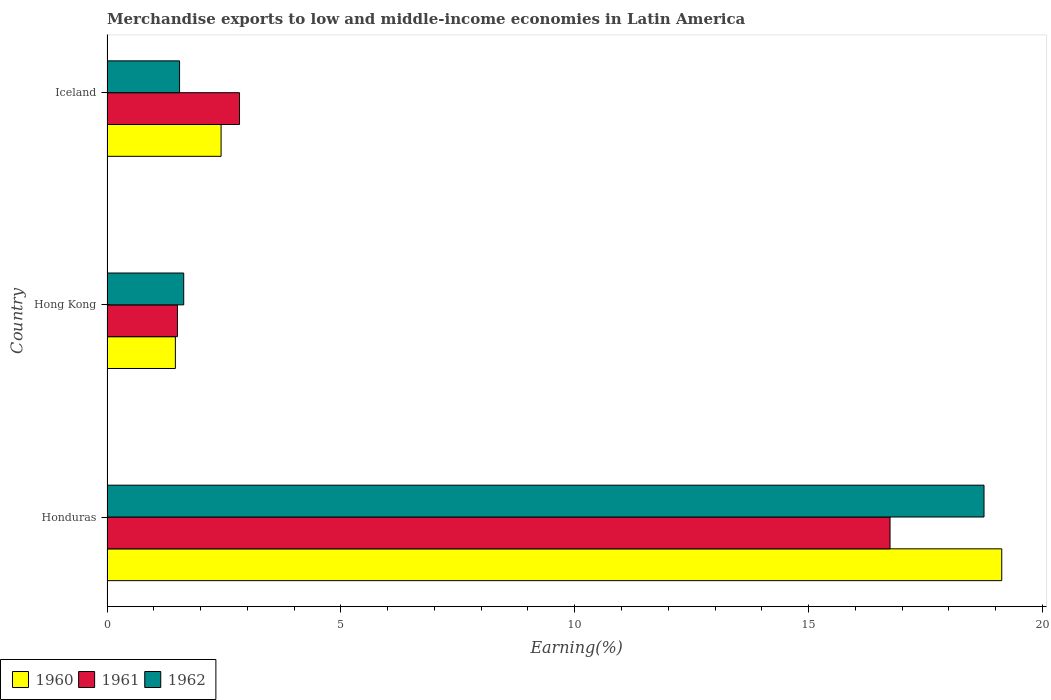How many different coloured bars are there?
Provide a short and direct response. 3. How many groups of bars are there?
Your response must be concise. 3. Are the number of bars per tick equal to the number of legend labels?
Make the answer very short. Yes. In how many cases, is the number of bars for a given country not equal to the number of legend labels?
Your answer should be compact. 0. What is the percentage of amount earned from merchandise exports in 1960 in Honduras?
Provide a succinct answer. 19.13. Across all countries, what is the maximum percentage of amount earned from merchandise exports in 1960?
Ensure brevity in your answer.  19.13. Across all countries, what is the minimum percentage of amount earned from merchandise exports in 1960?
Your answer should be very brief. 1.46. In which country was the percentage of amount earned from merchandise exports in 1961 maximum?
Offer a very short reply. Honduras. What is the total percentage of amount earned from merchandise exports in 1962 in the graph?
Offer a very short reply. 21.94. What is the difference between the percentage of amount earned from merchandise exports in 1962 in Honduras and that in Hong Kong?
Give a very brief answer. 17.11. What is the difference between the percentage of amount earned from merchandise exports in 1962 in Hong Kong and the percentage of amount earned from merchandise exports in 1960 in Honduras?
Offer a very short reply. -17.49. What is the average percentage of amount earned from merchandise exports in 1960 per country?
Provide a succinct answer. 7.68. What is the difference between the percentage of amount earned from merchandise exports in 1960 and percentage of amount earned from merchandise exports in 1961 in Honduras?
Ensure brevity in your answer.  2.39. In how many countries, is the percentage of amount earned from merchandise exports in 1962 greater than 10 %?
Make the answer very short. 1. What is the ratio of the percentage of amount earned from merchandise exports in 1962 in Honduras to that in Hong Kong?
Provide a short and direct response. 11.43. Is the percentage of amount earned from merchandise exports in 1960 in Hong Kong less than that in Iceland?
Your response must be concise. Yes. Is the difference between the percentage of amount earned from merchandise exports in 1960 in Honduras and Iceland greater than the difference between the percentage of amount earned from merchandise exports in 1961 in Honduras and Iceland?
Ensure brevity in your answer.  Yes. What is the difference between the highest and the second highest percentage of amount earned from merchandise exports in 1962?
Ensure brevity in your answer.  17.11. What is the difference between the highest and the lowest percentage of amount earned from merchandise exports in 1960?
Your answer should be very brief. 17.67. In how many countries, is the percentage of amount earned from merchandise exports in 1962 greater than the average percentage of amount earned from merchandise exports in 1962 taken over all countries?
Keep it short and to the point. 1. What does the 2nd bar from the bottom in Iceland represents?
Your answer should be very brief. 1961. Is it the case that in every country, the sum of the percentage of amount earned from merchandise exports in 1962 and percentage of amount earned from merchandise exports in 1961 is greater than the percentage of amount earned from merchandise exports in 1960?
Give a very brief answer. Yes. How many countries are there in the graph?
Offer a terse response. 3. How are the legend labels stacked?
Provide a succinct answer. Horizontal. What is the title of the graph?
Your response must be concise. Merchandise exports to low and middle-income economies in Latin America. Does "1981" appear as one of the legend labels in the graph?
Keep it short and to the point. No. What is the label or title of the X-axis?
Your answer should be compact. Earning(%). What is the Earning(%) in 1960 in Honduras?
Give a very brief answer. 19.13. What is the Earning(%) in 1961 in Honduras?
Your answer should be compact. 16.74. What is the Earning(%) of 1962 in Honduras?
Offer a very short reply. 18.75. What is the Earning(%) in 1960 in Hong Kong?
Make the answer very short. 1.46. What is the Earning(%) in 1961 in Hong Kong?
Offer a terse response. 1.51. What is the Earning(%) in 1962 in Hong Kong?
Your response must be concise. 1.64. What is the Earning(%) in 1960 in Iceland?
Your answer should be compact. 2.44. What is the Earning(%) in 1961 in Iceland?
Offer a terse response. 2.83. What is the Earning(%) of 1962 in Iceland?
Your response must be concise. 1.55. Across all countries, what is the maximum Earning(%) in 1960?
Provide a short and direct response. 19.13. Across all countries, what is the maximum Earning(%) of 1961?
Offer a terse response. 16.74. Across all countries, what is the maximum Earning(%) in 1962?
Offer a very short reply. 18.75. Across all countries, what is the minimum Earning(%) of 1960?
Your answer should be compact. 1.46. Across all countries, what is the minimum Earning(%) in 1961?
Offer a very short reply. 1.51. Across all countries, what is the minimum Earning(%) of 1962?
Offer a very short reply. 1.55. What is the total Earning(%) in 1960 in the graph?
Offer a terse response. 23.03. What is the total Earning(%) of 1961 in the graph?
Ensure brevity in your answer.  21.08. What is the total Earning(%) of 1962 in the graph?
Your answer should be very brief. 21.94. What is the difference between the Earning(%) of 1960 in Honduras and that in Hong Kong?
Give a very brief answer. 17.67. What is the difference between the Earning(%) in 1961 in Honduras and that in Hong Kong?
Provide a short and direct response. 15.24. What is the difference between the Earning(%) of 1962 in Honduras and that in Hong Kong?
Your response must be concise. 17.11. What is the difference between the Earning(%) of 1960 in Honduras and that in Iceland?
Your response must be concise. 16.69. What is the difference between the Earning(%) in 1961 in Honduras and that in Iceland?
Ensure brevity in your answer.  13.91. What is the difference between the Earning(%) in 1962 in Honduras and that in Iceland?
Keep it short and to the point. 17.2. What is the difference between the Earning(%) of 1960 in Hong Kong and that in Iceland?
Give a very brief answer. -0.98. What is the difference between the Earning(%) in 1961 in Hong Kong and that in Iceland?
Your answer should be very brief. -1.33. What is the difference between the Earning(%) of 1962 in Hong Kong and that in Iceland?
Give a very brief answer. 0.09. What is the difference between the Earning(%) in 1960 in Honduras and the Earning(%) in 1961 in Hong Kong?
Offer a very short reply. 17.62. What is the difference between the Earning(%) of 1960 in Honduras and the Earning(%) of 1962 in Hong Kong?
Keep it short and to the point. 17.49. What is the difference between the Earning(%) in 1961 in Honduras and the Earning(%) in 1962 in Hong Kong?
Ensure brevity in your answer.  15.1. What is the difference between the Earning(%) of 1960 in Honduras and the Earning(%) of 1961 in Iceland?
Your response must be concise. 16.3. What is the difference between the Earning(%) in 1960 in Honduras and the Earning(%) in 1962 in Iceland?
Your answer should be compact. 17.58. What is the difference between the Earning(%) in 1961 in Honduras and the Earning(%) in 1962 in Iceland?
Provide a short and direct response. 15.19. What is the difference between the Earning(%) in 1960 in Hong Kong and the Earning(%) in 1961 in Iceland?
Provide a succinct answer. -1.37. What is the difference between the Earning(%) of 1960 in Hong Kong and the Earning(%) of 1962 in Iceland?
Your answer should be compact. -0.09. What is the difference between the Earning(%) in 1961 in Hong Kong and the Earning(%) in 1962 in Iceland?
Offer a terse response. -0.05. What is the average Earning(%) of 1960 per country?
Give a very brief answer. 7.68. What is the average Earning(%) in 1961 per country?
Keep it short and to the point. 7.03. What is the average Earning(%) of 1962 per country?
Your answer should be very brief. 7.31. What is the difference between the Earning(%) in 1960 and Earning(%) in 1961 in Honduras?
Your answer should be compact. 2.39. What is the difference between the Earning(%) in 1960 and Earning(%) in 1962 in Honduras?
Your answer should be very brief. 0.38. What is the difference between the Earning(%) of 1961 and Earning(%) of 1962 in Honduras?
Offer a terse response. -2.01. What is the difference between the Earning(%) in 1960 and Earning(%) in 1961 in Hong Kong?
Keep it short and to the point. -0.04. What is the difference between the Earning(%) of 1960 and Earning(%) of 1962 in Hong Kong?
Your answer should be very brief. -0.18. What is the difference between the Earning(%) in 1961 and Earning(%) in 1962 in Hong Kong?
Provide a short and direct response. -0.13. What is the difference between the Earning(%) in 1960 and Earning(%) in 1961 in Iceland?
Ensure brevity in your answer.  -0.39. What is the difference between the Earning(%) in 1960 and Earning(%) in 1962 in Iceland?
Give a very brief answer. 0.89. What is the difference between the Earning(%) in 1961 and Earning(%) in 1962 in Iceland?
Offer a terse response. 1.28. What is the ratio of the Earning(%) of 1960 in Honduras to that in Hong Kong?
Your answer should be very brief. 13.09. What is the ratio of the Earning(%) of 1961 in Honduras to that in Hong Kong?
Offer a very short reply. 11.12. What is the ratio of the Earning(%) in 1962 in Honduras to that in Hong Kong?
Your response must be concise. 11.43. What is the ratio of the Earning(%) in 1960 in Honduras to that in Iceland?
Your answer should be compact. 7.84. What is the ratio of the Earning(%) in 1961 in Honduras to that in Iceland?
Provide a succinct answer. 5.91. What is the ratio of the Earning(%) in 1962 in Honduras to that in Iceland?
Your answer should be very brief. 12.09. What is the ratio of the Earning(%) of 1960 in Hong Kong to that in Iceland?
Make the answer very short. 0.6. What is the ratio of the Earning(%) in 1961 in Hong Kong to that in Iceland?
Your answer should be very brief. 0.53. What is the ratio of the Earning(%) of 1962 in Hong Kong to that in Iceland?
Your answer should be compact. 1.06. What is the difference between the highest and the second highest Earning(%) of 1960?
Provide a succinct answer. 16.69. What is the difference between the highest and the second highest Earning(%) of 1961?
Offer a terse response. 13.91. What is the difference between the highest and the second highest Earning(%) in 1962?
Provide a succinct answer. 17.11. What is the difference between the highest and the lowest Earning(%) in 1960?
Your answer should be compact. 17.67. What is the difference between the highest and the lowest Earning(%) in 1961?
Give a very brief answer. 15.24. What is the difference between the highest and the lowest Earning(%) of 1962?
Give a very brief answer. 17.2. 